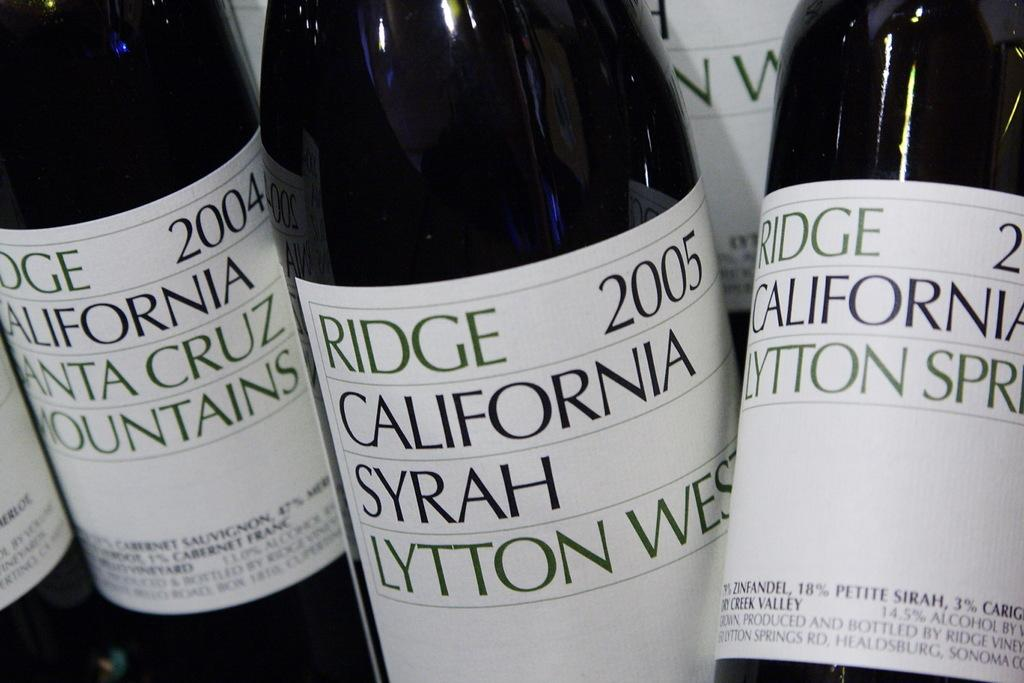Provide a one-sentence caption for the provided image. Bottles of wine by Ridge California Syrah Lytton West with 2005 on the label. 